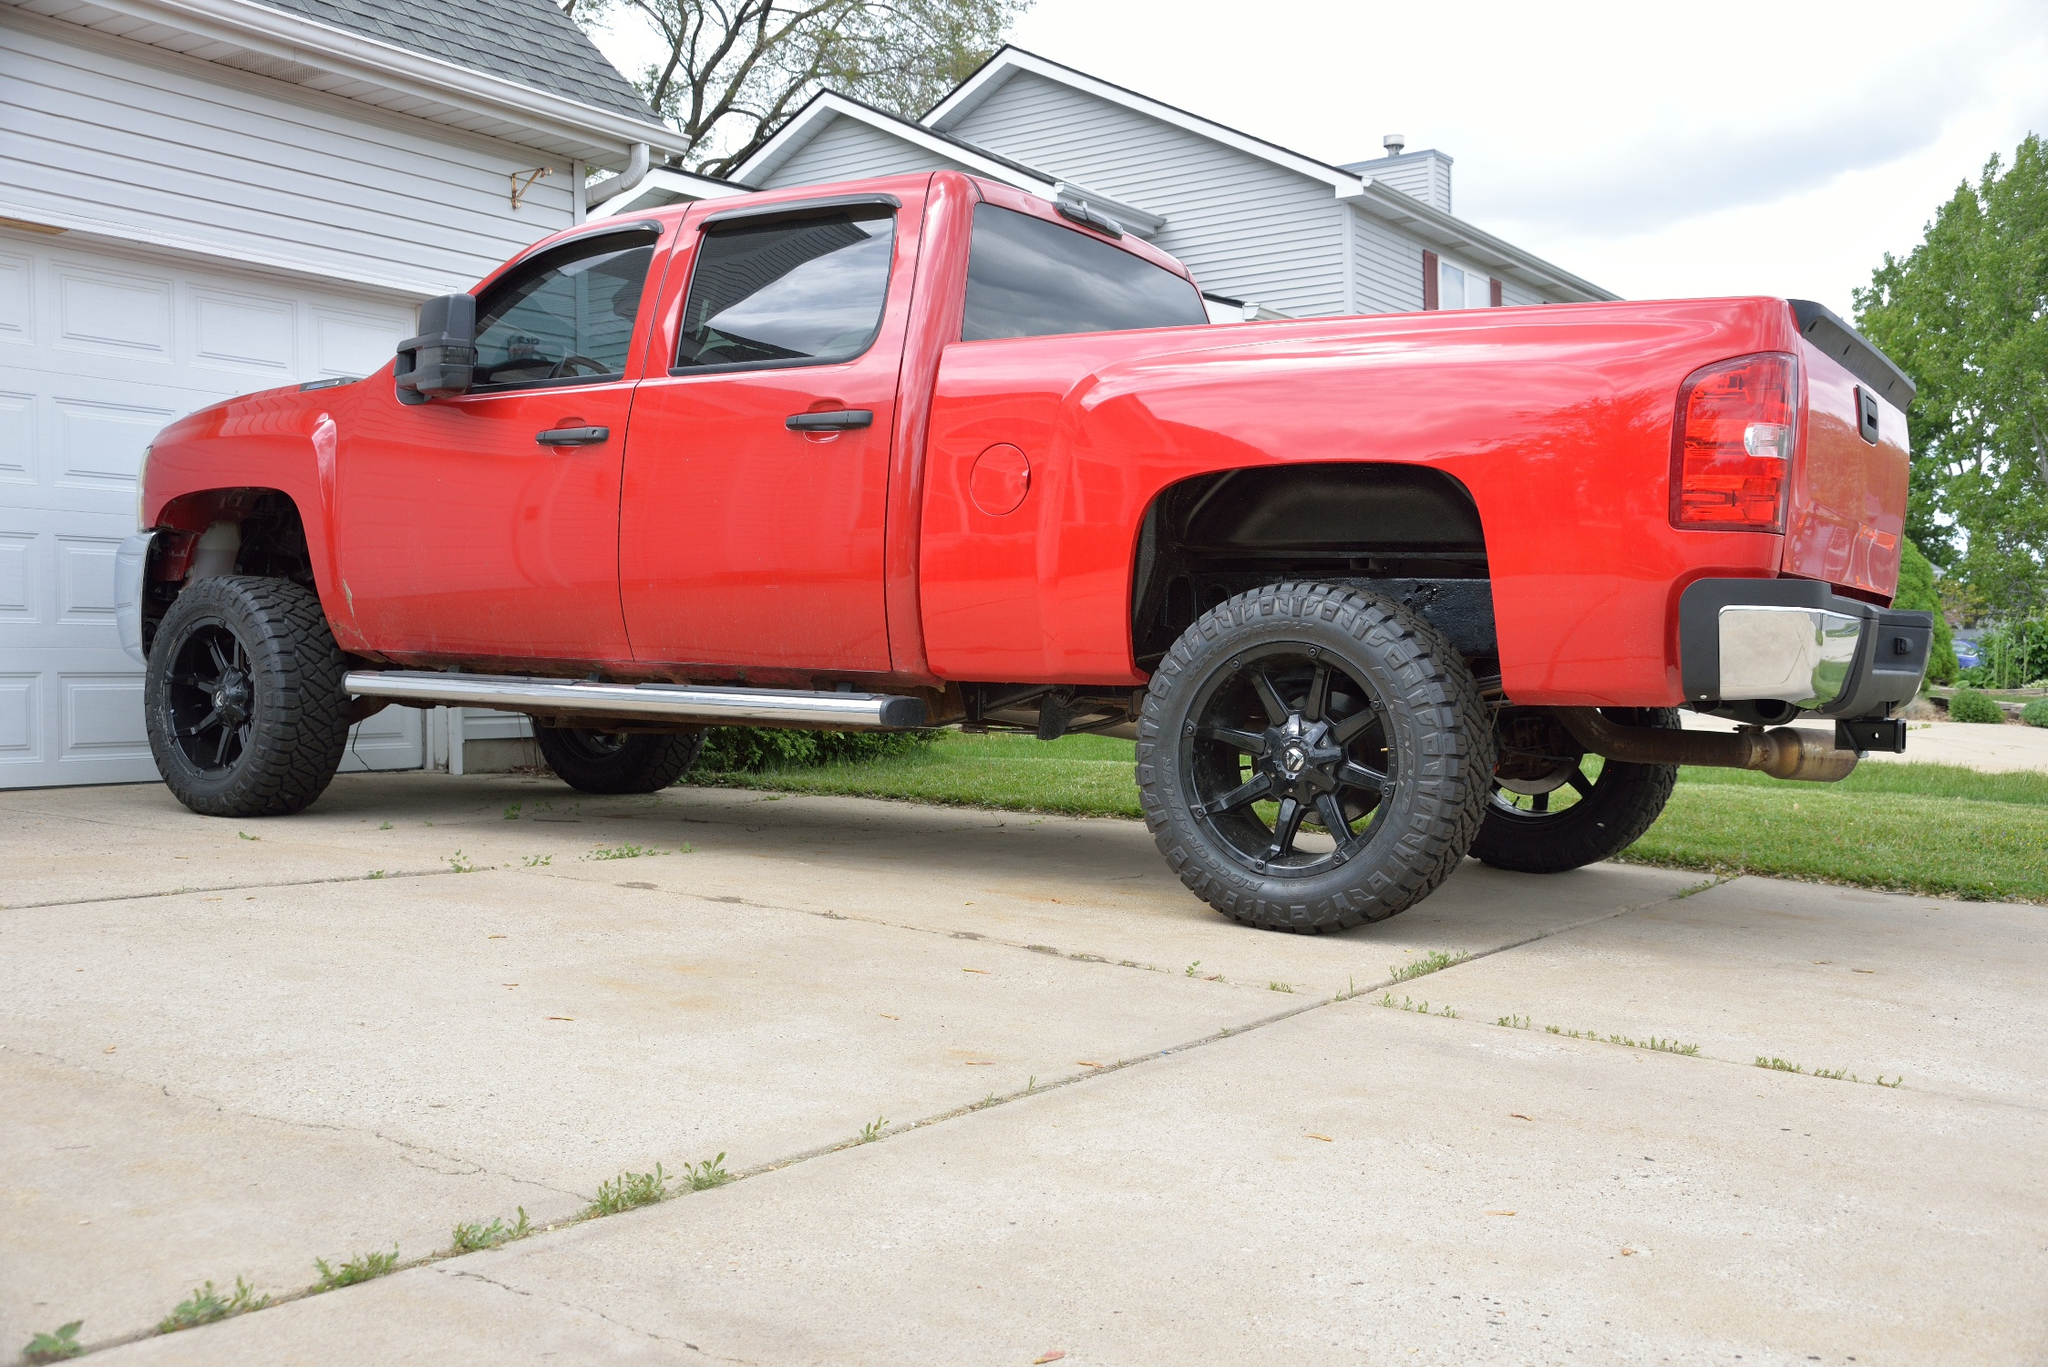Can you tell more about the design and features of this truck? The truck in the image is a red pickup with a body lifted significantly above the ground, suggesting enhanced suspension modifications. The black rims are robust and styled for both aesthetic appeal and durability. Features like the extended rearview mirrors indicate it may be equipped for towing, supporting its utility for hauling large loads. The presence of a step-up into the cab signifies its raised platform, which might make it a fitting choice for traversing rugged terrains. Overall, its design emphasizes a blend of functionality with a strong visual statement. What about the specifics of those black rims and tires? The black rims are crafted in a sporty, intricate design that not only enhances the visual appeal but also suggests durability for handling rough terrains. They are paired with large, tread-heavy tires that are optimal for providing traction on off-road trails or uneven surfaces. These tires are likely to offer a balance between on-road comfort and off-road capability, suiting drivers who venture beyond typical city roads. 